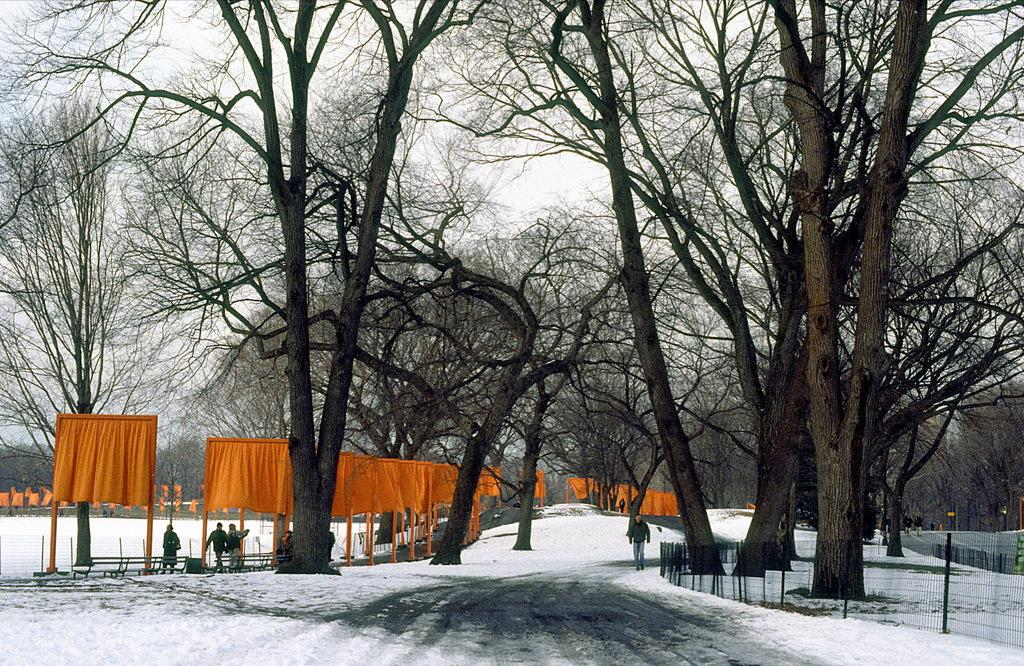What type of vegetation can be seen in the image? There are trees in the image. What is hanging on the poles in the image? There are orange color clothes on poles. What are the people in the image doing? There are people walking in the image. What type of barrier is present in the image? There is a metal fence in the image. What is covering the ground in the image? There is snow on the ground in the image. What is the condition of the sky in the image? The sky is cloudy in the image. How many masses are visible in the image? There is no mass present in the image. What type of coat can be seen on the people walking in the image? The image does not show the type of coats the people are wearing, if any. 